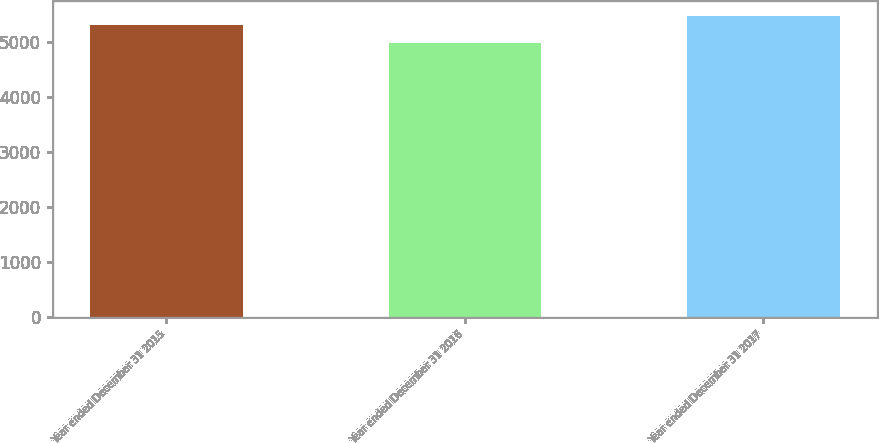Convert chart. <chart><loc_0><loc_0><loc_500><loc_500><bar_chart><fcel>Year ended December 31 2015<fcel>Year ended December 31 2016<fcel>Year ended December 31 2017<nl><fcel>5326<fcel>4988<fcel>5488<nl></chart> 